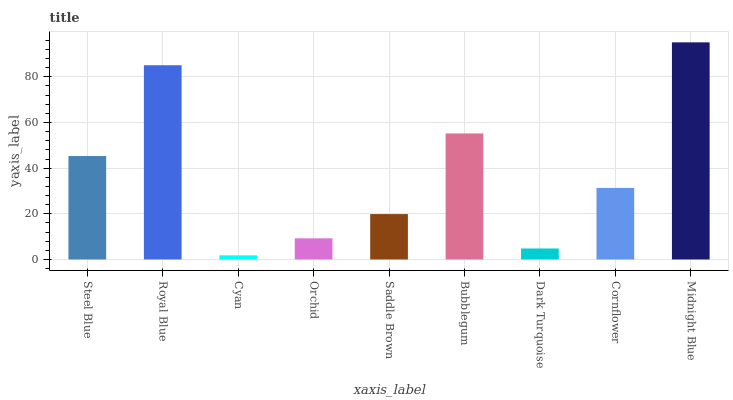Is Royal Blue the minimum?
Answer yes or no. No. Is Royal Blue the maximum?
Answer yes or no. No. Is Royal Blue greater than Steel Blue?
Answer yes or no. Yes. Is Steel Blue less than Royal Blue?
Answer yes or no. Yes. Is Steel Blue greater than Royal Blue?
Answer yes or no. No. Is Royal Blue less than Steel Blue?
Answer yes or no. No. Is Cornflower the high median?
Answer yes or no. Yes. Is Cornflower the low median?
Answer yes or no. Yes. Is Royal Blue the high median?
Answer yes or no. No. Is Saddle Brown the low median?
Answer yes or no. No. 